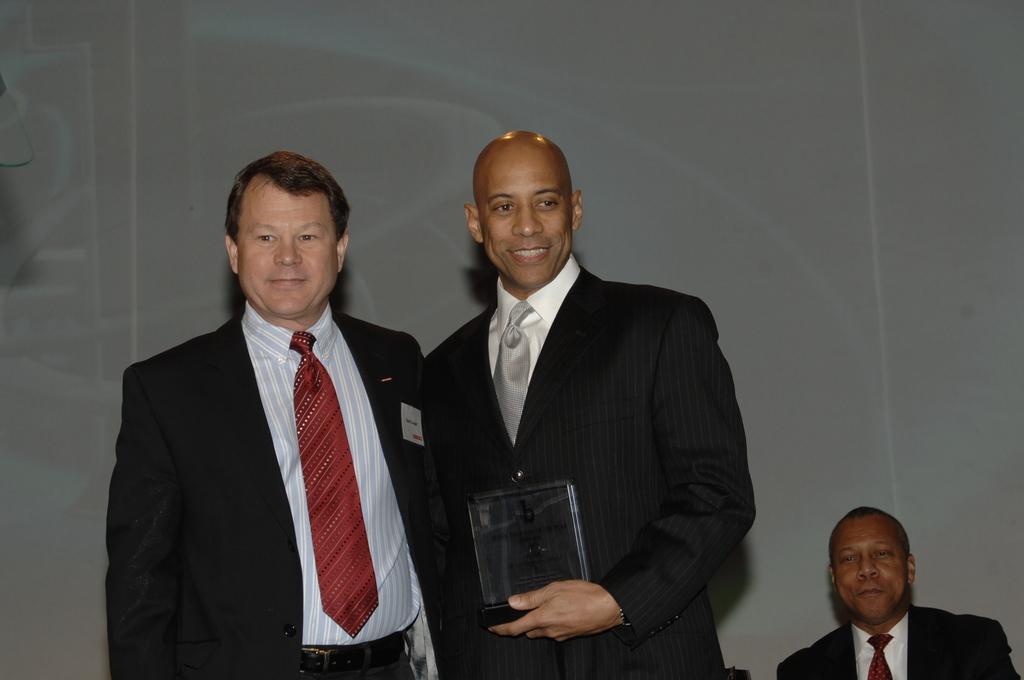In one or two sentences, can you explain what this image depicts? In this image we can see two men are standing and the right side man is holding a trophy in his hand. In the background there is a wall. On the right side at the bottom corner we can see a man. 